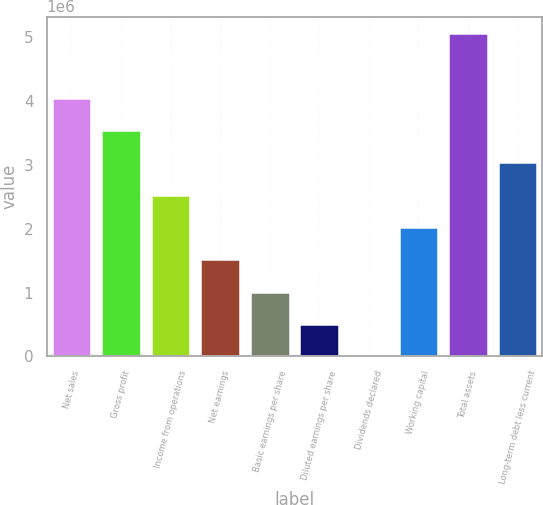Convert chart. <chart><loc_0><loc_0><loc_500><loc_500><bar_chart><fcel>Net sales<fcel>Gross profit<fcel>Income from operations<fcel>Net earnings<fcel>Basic earnings per share<fcel>Diluted earnings per share<fcel>Dividends declared<fcel>Working capital<fcel>Total assets<fcel>Long-term debt less current<nl><fcel>4.05562e+06<fcel>3.54867e+06<fcel>2.53476e+06<fcel>1.52086e+06<fcel>1.01391e+06<fcel>506953<fcel>0.4<fcel>2.02781e+06<fcel>5.06952e+06<fcel>3.04171e+06<nl></chart> 